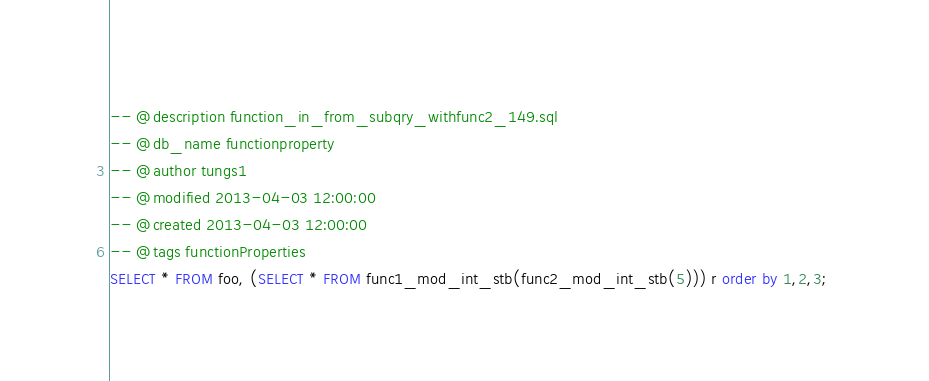<code> <loc_0><loc_0><loc_500><loc_500><_SQL_>-- @description function_in_from_subqry_withfunc2_149.sql
-- @db_name functionproperty
-- @author tungs1
-- @modified 2013-04-03 12:00:00
-- @created 2013-04-03 12:00:00
-- @tags functionProperties 
SELECT * FROM foo, (SELECT * FROM func1_mod_int_stb(func2_mod_int_stb(5))) r order by 1,2,3; 
</code> 